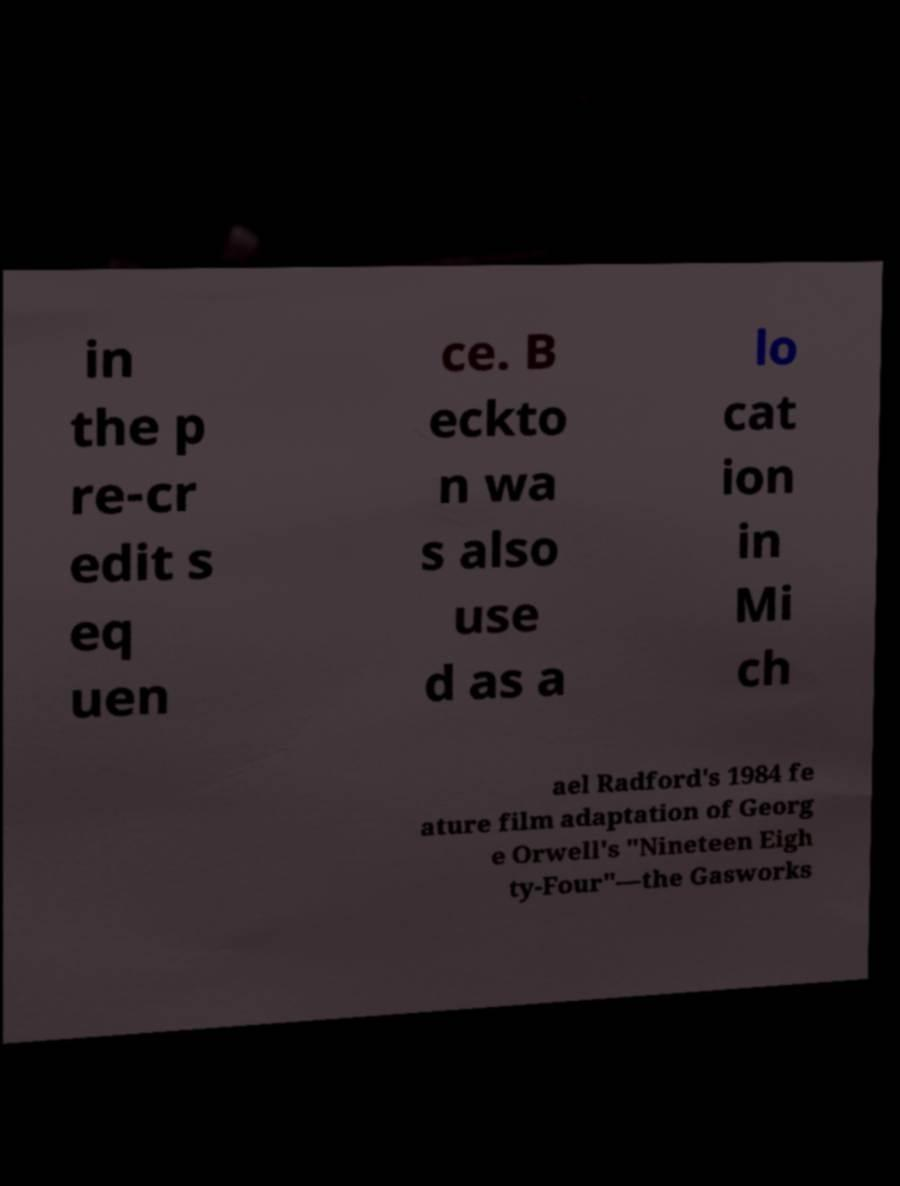Please read and relay the text visible in this image. What does it say? in the p re-cr edit s eq uen ce. B eckto n wa s also use d as a lo cat ion in Mi ch ael Radford's 1984 fe ature film adaptation of Georg e Orwell's "Nineteen Eigh ty-Four"—the Gasworks 